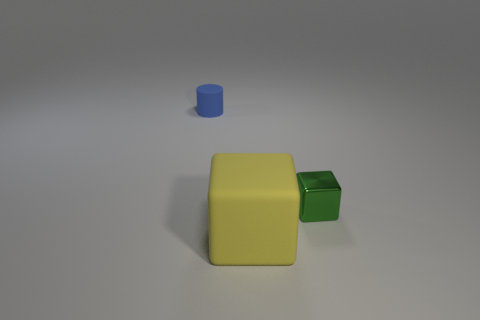Add 2 blue rubber cylinders. How many objects exist? 5 Subtract all cubes. How many objects are left? 1 Subtract 0 brown cylinders. How many objects are left? 3 Subtract all green metal cubes. Subtract all tiny cubes. How many objects are left? 1 Add 2 metallic blocks. How many metallic blocks are left? 3 Add 2 blue matte objects. How many blue matte objects exist? 3 